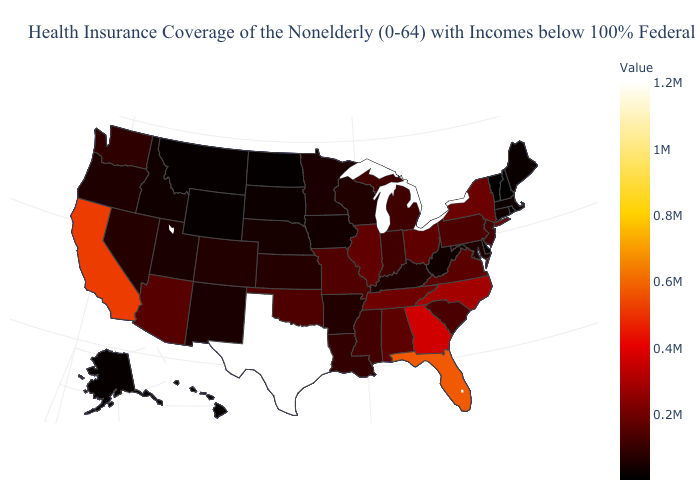Is the legend a continuous bar?
Answer briefly. Yes. Does New York have the highest value in the Northeast?
Write a very short answer. Yes. Among the states that border Mississippi , which have the highest value?
Quick response, please. Tennessee. Does the map have missing data?
Give a very brief answer. No. Among the states that border Missouri , does Tennessee have the highest value?
Be succinct. Yes. Does the map have missing data?
Quick response, please. No. Is the legend a continuous bar?
Concise answer only. Yes. 